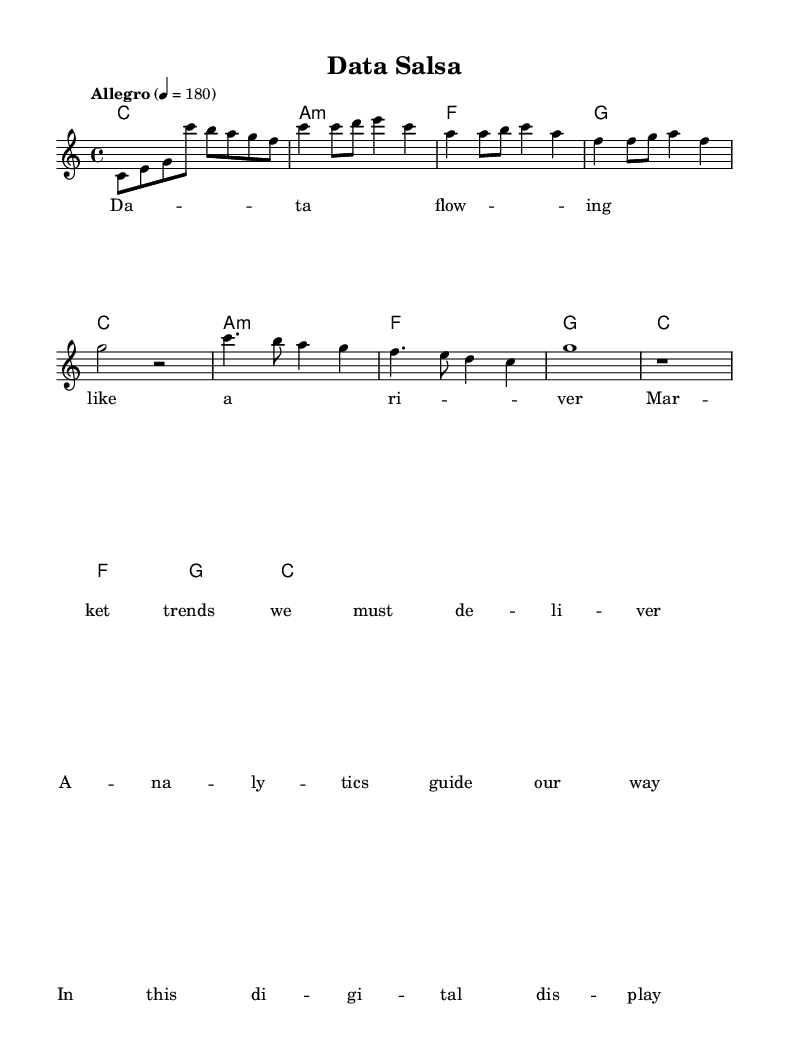What is the key signature of this music? The key signature is C major, which has no sharps or flats.
Answer: C major What is the time signature of this piece? The time signature is indicated at the beginning of the score, showing how many beats are in a measure and which note value is a beat, which is 4 beats per measure.
Answer: 4/4 What is the tempo marking for this piece? The tempo marking indicates the speed of the music, which is stated at the beginning as "Allegro" with a metronome marking of 180 beats per minute.
Answer: Allegro, 4 = 180 How many measures are in the chorus section? By counting the measures that contain the chorus lyrics in the sheet music, we can determine the total number of measures used in this section. The chorus has four measures.
Answer: 4 What is the relationship between the melody and harmonies in this piece? The melody corresponds with the harmonies by following the chord progressions, which provide a supportive structure for the melody notes, typically based around the underlying chords during each section of the music. Here, the melody aligns with the harmonies in the C major, A minor, F, and G chords.
Answer: Complementary What unique elements connect this music to Latin American salsa? The incorporation of rhythmic elements and syncopation typical in Latin American salsa music can be identified in the upbeat tempo and lively style of the melody and chord progressions, along with the dance-like quality in the lyrics.
Answer: Rhythmic elements, syncopation What does the first line of the verse lyrics signify about data flow in market analysis? The first line compares data flow to a river, illustrating the continuous movement and importance of data in the context of market trends and analytics, emphasizing the necessity of timely and effective delivery of information.
Answer: Continuous movement of data 